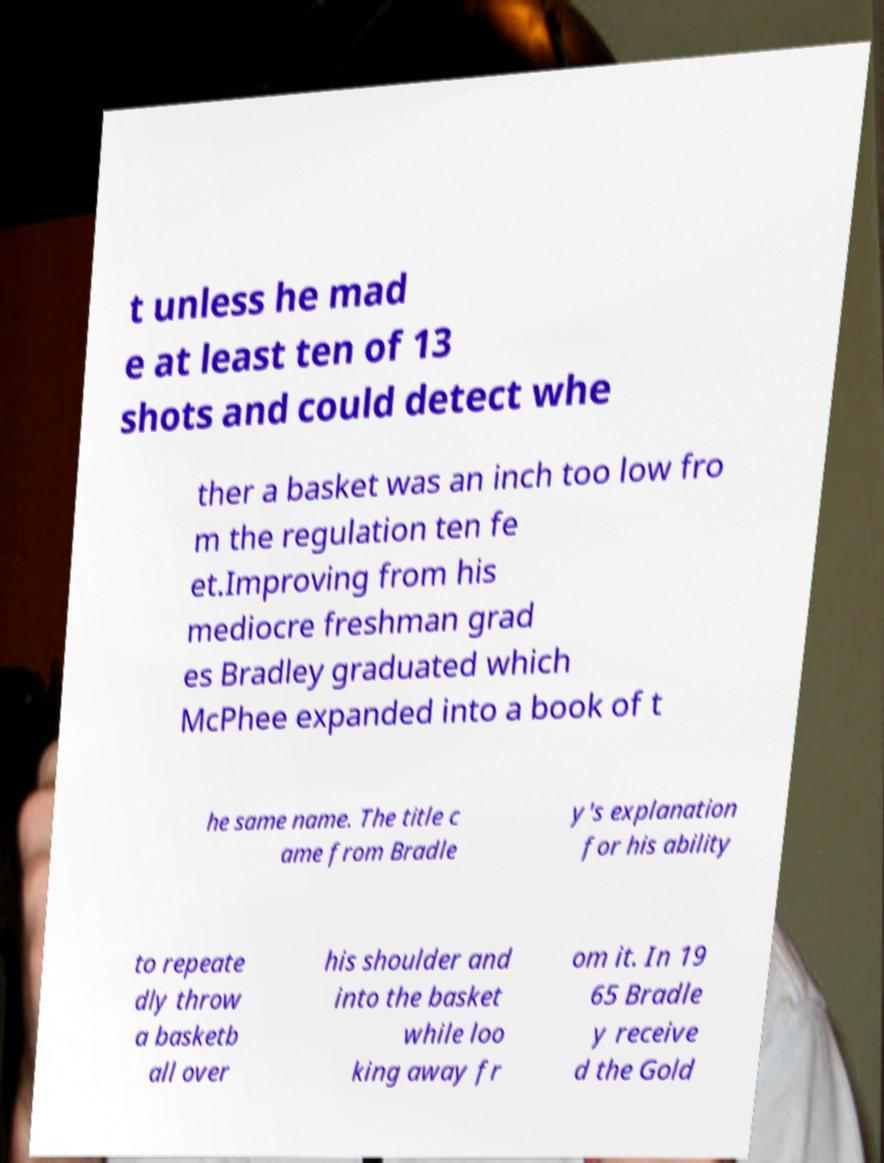Could you assist in decoding the text presented in this image and type it out clearly? t unless he mad e at least ten of 13 shots and could detect whe ther a basket was an inch too low fro m the regulation ten fe et.Improving from his mediocre freshman grad es Bradley graduated which McPhee expanded into a book of t he same name. The title c ame from Bradle y's explanation for his ability to repeate dly throw a basketb all over his shoulder and into the basket while loo king away fr om it. In 19 65 Bradle y receive d the Gold 